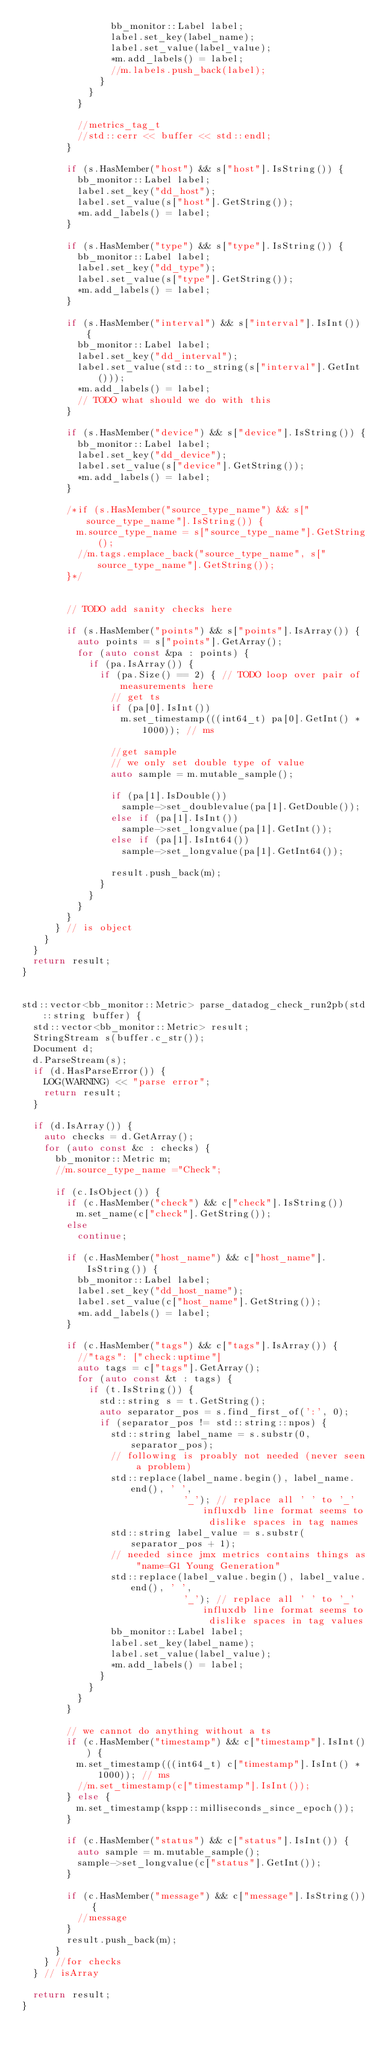Convert code to text. <code><loc_0><loc_0><loc_500><loc_500><_C++_>                bb_monitor::Label label;
                label.set_key(label_name);
                label.set_value(label_value);
                *m.add_labels() = label;
                //m.labels.push_back(label);
              }
            }
          }

          //metrics_tag_t
          //std::cerr << buffer << std::endl;
        }

        if (s.HasMember("host") && s["host"].IsString()) {
          bb_monitor::Label label;
          label.set_key("dd_host");
          label.set_value(s["host"].GetString());
          *m.add_labels() = label;
        }

        if (s.HasMember("type") && s["type"].IsString()) {
          bb_monitor::Label label;
          label.set_key("dd_type");
          label.set_value(s["type"].GetString());
          *m.add_labels() = label;
        }

        if (s.HasMember("interval") && s["interval"].IsInt()) {
          bb_monitor::Label label;
          label.set_key("dd_interval");
          label.set_value(std::to_string(s["interval"].GetInt()));
          *m.add_labels() = label;
          // TODO what should we do with this
        }

        if (s.HasMember("device") && s["device"].IsString()) {
          bb_monitor::Label label;
          label.set_key("dd_device");
          label.set_value(s["device"].GetString());
          *m.add_labels() = label;
        }

        /*if (s.HasMember("source_type_name") && s["source_type_name"].IsString()) {
          m.source_type_name = s["source_type_name"].GetString();
          //m.tags.emplace_back("source_type_name", s["source_type_name"].GetString());
        }*/


        // TODO add sanity checks here

        if (s.HasMember("points") && s["points"].IsArray()) {
          auto points = s["points"].GetArray();
          for (auto const &pa : points) {
            if (pa.IsArray()) {
              if (pa.Size() == 2) { // TODO loop over pair of measurements here
                // get ts
                if (pa[0].IsInt())
                  m.set_timestamp(((int64_t) pa[0].GetInt() * 1000)); // ms

                //get sample
                // we only set double type of value
                auto sample = m.mutable_sample();

                if (pa[1].IsDouble())
                  sample->set_doublevalue(pa[1].GetDouble());
                else if (pa[1].IsInt())
                  sample->set_longvalue(pa[1].GetInt());
                else if (pa[1].IsInt64())
                  sample->set_longvalue(pa[1].GetInt64());

                result.push_back(m);
              }
            }
          }
        }
      } // is object
    }
  }
  return result;
}


std::vector<bb_monitor::Metric> parse_datadog_check_run2pb(std::string buffer) {
  std::vector<bb_monitor::Metric> result;
  StringStream s(buffer.c_str());
  Document d;
  d.ParseStream(s);
  if (d.HasParseError()) {
    LOG(WARNING) << "parse error";
    return result;
  }

  if (d.IsArray()) {
    auto checks = d.GetArray();
    for (auto const &c : checks) {
      bb_monitor::Metric m;
      //m.source_type_name ="Check";

      if (c.IsObject()) {
        if (c.HasMember("check") && c["check"].IsString())
          m.set_name(c["check"].GetString());
        else
          continue;

        if (c.HasMember("host_name") && c["host_name"].IsString()) {
          bb_monitor::Label label;
          label.set_key("dd_host_name");
          label.set_value(c["host_name"].GetString());
          *m.add_labels() = label;
        }

        if (c.HasMember("tags") && c["tags"].IsArray()) {
          //"tags": ["check:uptime"]
          auto tags = c["tags"].GetArray();
          for (auto const &t : tags) {
            if (t.IsString()) {
              std::string s = t.GetString();
              auto separator_pos = s.find_first_of(':', 0);
              if (separator_pos != std::string::npos) {
                std::string label_name = s.substr(0, separator_pos);
                // following is proably not needed (never seen a problem)
                std::replace(label_name.begin(), label_name.end(), ' ',
                             '_'); // replace all ' ' to '_' influxdb line format seems to dislike spaces in tag names
                std::string label_value = s.substr(separator_pos + 1);
                // needed since jmx metrics contains things as "name=G1 Young Generation"
                std::replace(label_value.begin(), label_value.end(), ' ',
                             '_'); // replace all ' ' to '_' influxdb line format seems to dislike spaces in tag values
                bb_monitor::Label label;
                label.set_key(label_name);
                label.set_value(label_value);
                *m.add_labels() = label;
              }
            }
          }
        }

        // we cannot do anything without a ts
        if (c.HasMember("timestamp") && c["timestamp"].IsInt()) {
          m.set_timestamp(((int64_t) c["timestamp"].IsInt() * 1000)); // ms
          //m.set_timestamp(c["timestamp"].IsInt());
        } else {
          m.set_timestamp(kspp::milliseconds_since_epoch());
        }

        if (c.HasMember("status") && c["status"].IsInt()) {
          auto sample = m.mutable_sample();
          sample->set_longvalue(c["status"].GetInt());
        }

        if (c.HasMember("message") && c["message"].IsString()) {
          //message
        }
        result.push_back(m);
      }
    } //for checks
  } // isArray

  return result;
}


</code> 